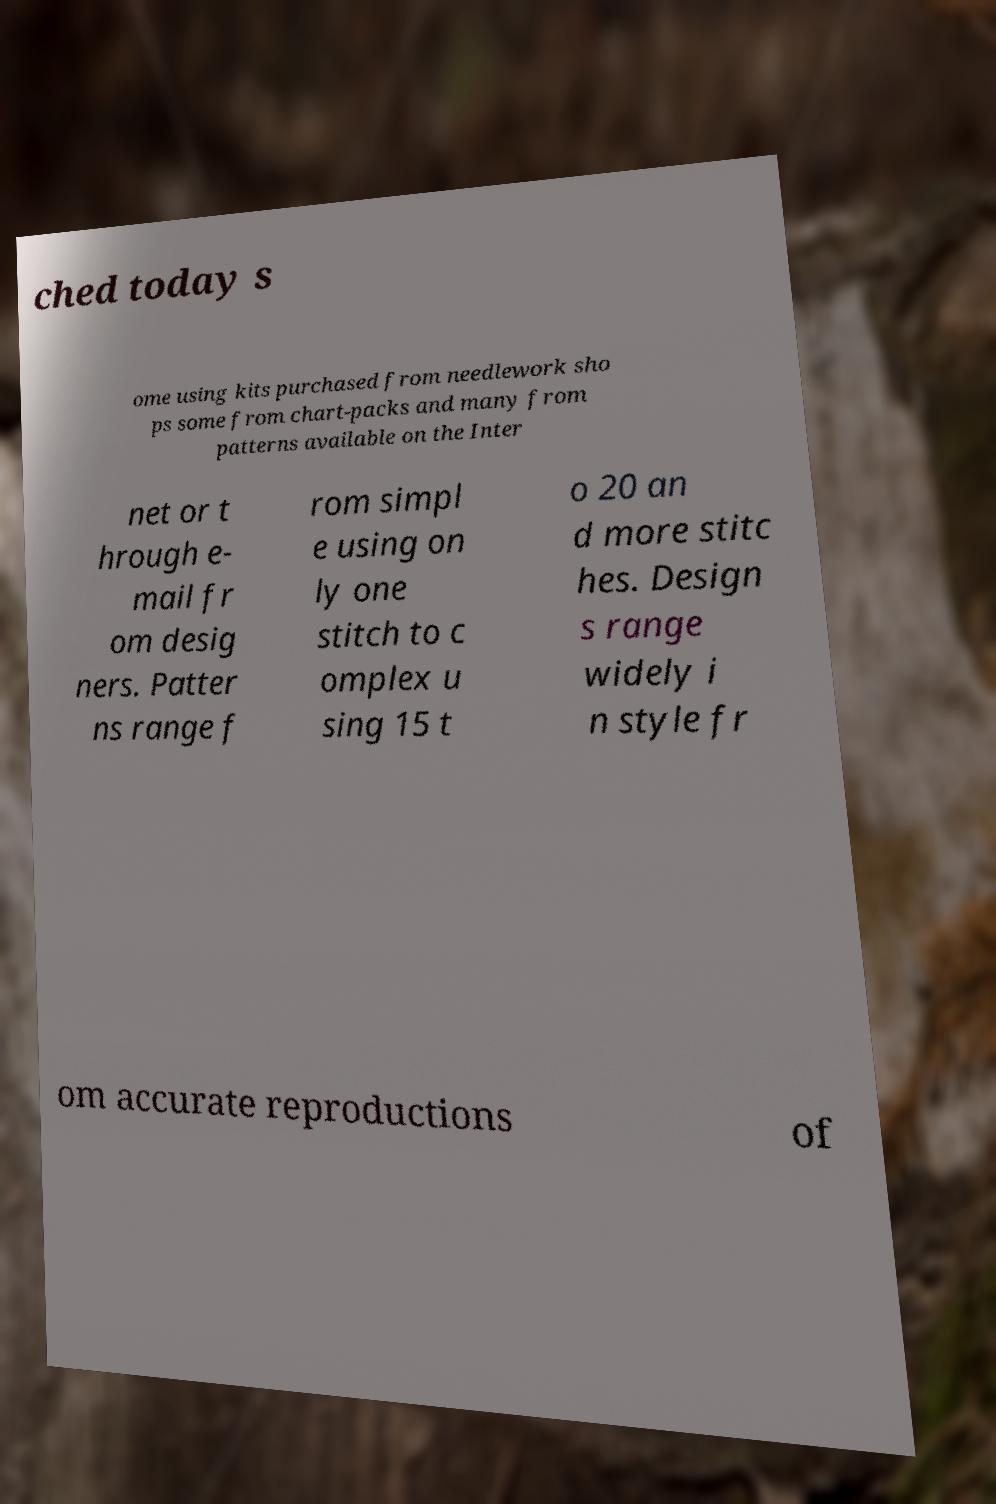I need the written content from this picture converted into text. Can you do that? ched today s ome using kits purchased from needlework sho ps some from chart-packs and many from patterns available on the Inter net or t hrough e- mail fr om desig ners. Patter ns range f rom simpl e using on ly one stitch to c omplex u sing 15 t o 20 an d more stitc hes. Design s range widely i n style fr om accurate reproductions of 